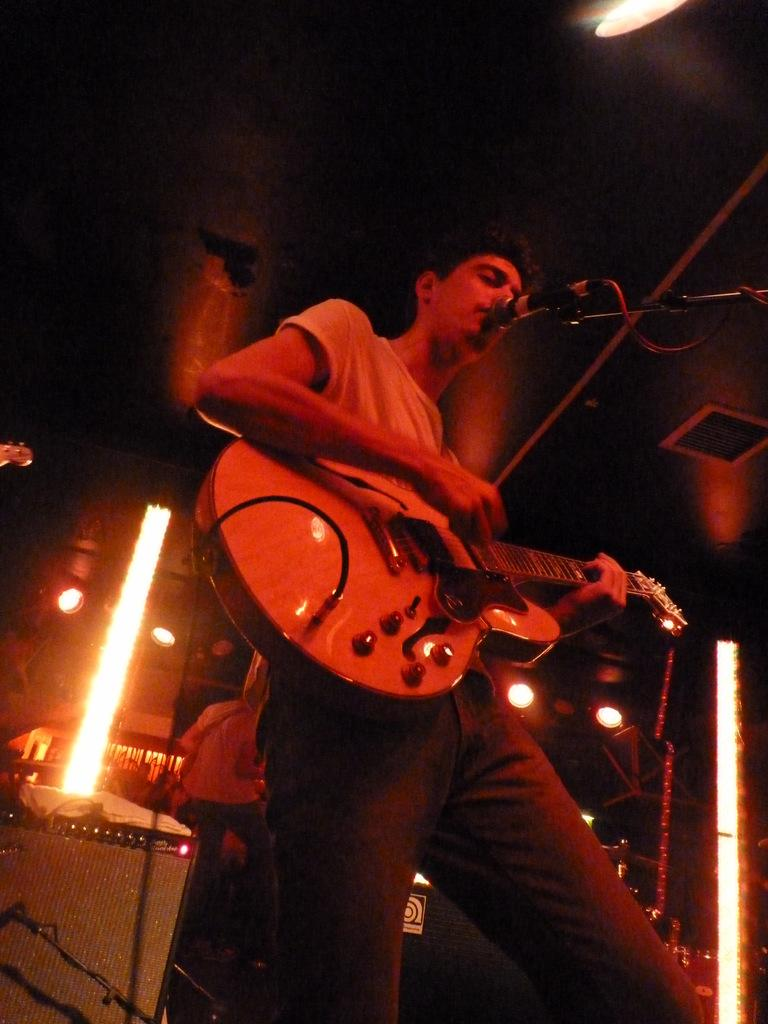What is the main activity of the person in the image? The person is playing guitar and singing on a mic. What other objects or people are present in the image? There are musical instruments and another person in the background, as well as a light. How many cows are visible in the image? There are no cows present in the image. What type of approval is the person singing on the mic seeking from the audience? The image does not provide any information about the person's intentions or the audience's reactions, so it is not possible to determine if they are seeking any type of approval. 